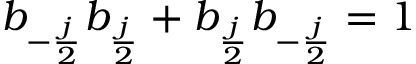<formula> <loc_0><loc_0><loc_500><loc_500>b _ { - { \frac { j } { 2 } } } b _ { { \frac { j } { 2 } } } + b _ { { \frac { j } { 2 } } } b _ { - { \frac { j } { 2 } } } = 1</formula> 